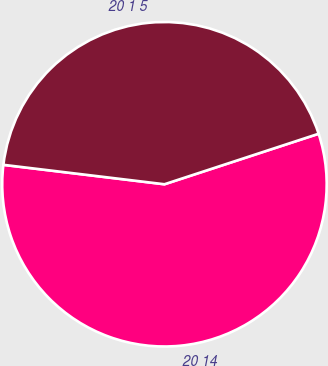<chart> <loc_0><loc_0><loc_500><loc_500><pie_chart><fcel>20 14<fcel>20 1 5<nl><fcel>56.95%<fcel>43.05%<nl></chart> 